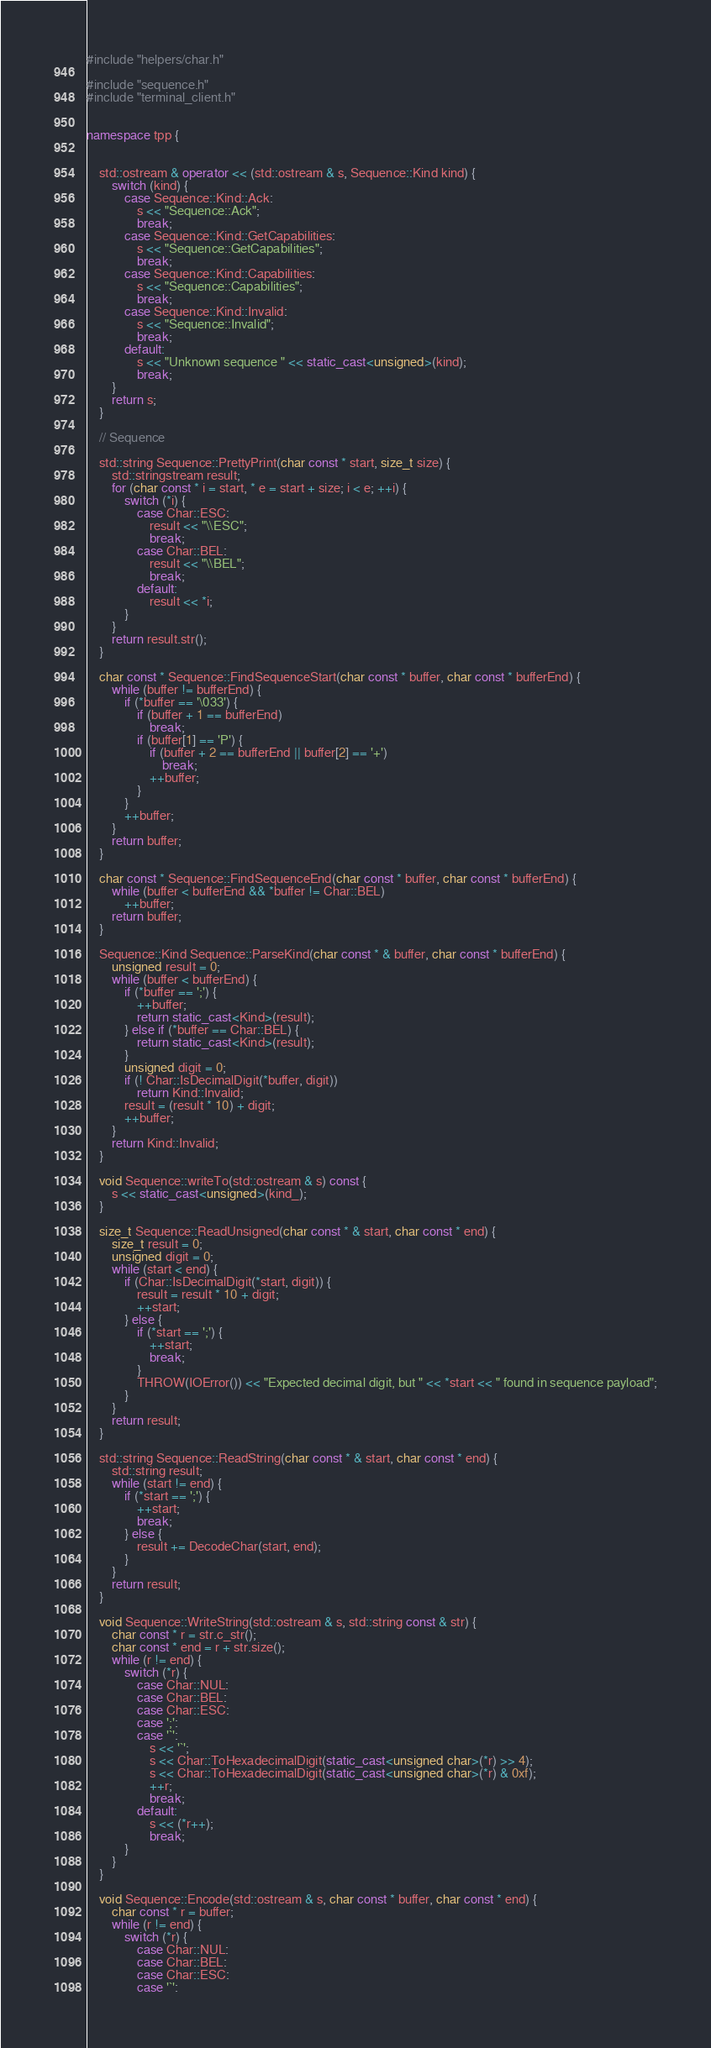<code> <loc_0><loc_0><loc_500><loc_500><_C++_>#include "helpers/char.h"

#include "sequence.h"
#include "terminal_client.h"


namespace tpp {


    std::ostream & operator << (std::ostream & s, Sequence::Kind kind) {
        switch (kind) {
            case Sequence::Kind::Ack:
                s << "Sequence::Ack";
                break;
            case Sequence::Kind::GetCapabilities:
                s << "Sequence::GetCapabilities";
                break;
            case Sequence::Kind::Capabilities:
                s << "Sequence::Capabilities";
                break;
            case Sequence::Kind::Invalid:
                s << "Sequence::Invalid";
                break;
            default:
                s << "Unknown sequence " << static_cast<unsigned>(kind);
                break;
        }
        return s;
    }

    // Sequence

    std::string Sequence::PrettyPrint(char const * start, size_t size) {
        std::stringstream result;
        for (char const * i = start, * e = start + size; i < e; ++i) {
            switch (*i) {
                case Char::ESC:
                    result << "\\ESC";
                    break;
                case Char::BEL:
                    result << "\\BEL";
                    break;
                default:
                    result << *i;
            }
        }
        return result.str();
    }

    char const * Sequence::FindSequenceStart(char const * buffer, char const * bufferEnd) {
        while (buffer != bufferEnd) {
            if (*buffer == '\033') {
                if (buffer + 1 == bufferEnd)
                    break;
                if (buffer[1] == 'P') {
                    if (buffer + 2 == bufferEnd || buffer[2] == '+')
                        break;
                    ++buffer;
                } 
            }
            ++buffer;
        }
        return buffer;
    }

    char const * Sequence::FindSequenceEnd(char const * buffer, char const * bufferEnd) {
        while (buffer < bufferEnd && *buffer != Char::BEL)
            ++buffer;
        return buffer;
    }

    Sequence::Kind Sequence::ParseKind(char const * & buffer, char const * bufferEnd) {
        unsigned result = 0;
        while (buffer < bufferEnd) {
            if (*buffer == ';') {
                ++buffer;
                return static_cast<Kind>(result);
            } else if (*buffer == Char::BEL) {
                return static_cast<Kind>(result);
            }
            unsigned digit = 0;
            if (! Char::IsDecimalDigit(*buffer, digit))
                return Kind::Invalid;
            result = (result * 10) + digit;
            ++buffer;
        }
        return Kind::Invalid;
    }

    void Sequence::writeTo(std::ostream & s) const {
        s << static_cast<unsigned>(kind_);
    }

    size_t Sequence::ReadUnsigned(char const * & start, char const * end) {
        size_t result = 0;
        unsigned digit = 0;
        while (start < end) {
            if (Char::IsDecimalDigit(*start, digit)) {
                result = result * 10 + digit;
                ++start;
            } else {
                if (*start == ';') {
                    ++start;
                    break;
                }
                THROW(IOError()) << "Expected decimal digit, but " << *start << " found in sequence payload";
            }
        }
        return result;
    }

    std::string Sequence::ReadString(char const * & start, char const * end) {
        std::string result;
        while (start != end) {
            if (*start == ';') {
                ++start;
                break;
            } else {
                result += DecodeChar(start, end);
            }
        }
        return result;
    }

    void Sequence::WriteString(std::ostream & s, std::string const & str) {
        char const * r = str.c_str();
        char const * end = r + str.size();
        while (r != end) {
            switch (*r) {
                case Char::NUL:
                case Char::BEL:
                case Char::ESC:
                case ';':
                case '`':
                    s << '`';
                    s << Char::ToHexadecimalDigit(static_cast<unsigned char>(*r) >> 4);
                    s << Char::ToHexadecimalDigit(static_cast<unsigned char>(*r) & 0xf);
                    ++r;
                    break;
                default:
                    s << (*r++);
                    break;
            }
        }
    }

    void Sequence::Encode(std::ostream & s, char const * buffer, char const * end) {
        char const * r = buffer;
        while (r != end) {
            switch (*r) {
                case Char::NUL:
                case Char::BEL:
                case Char::ESC:
                case '`':</code> 